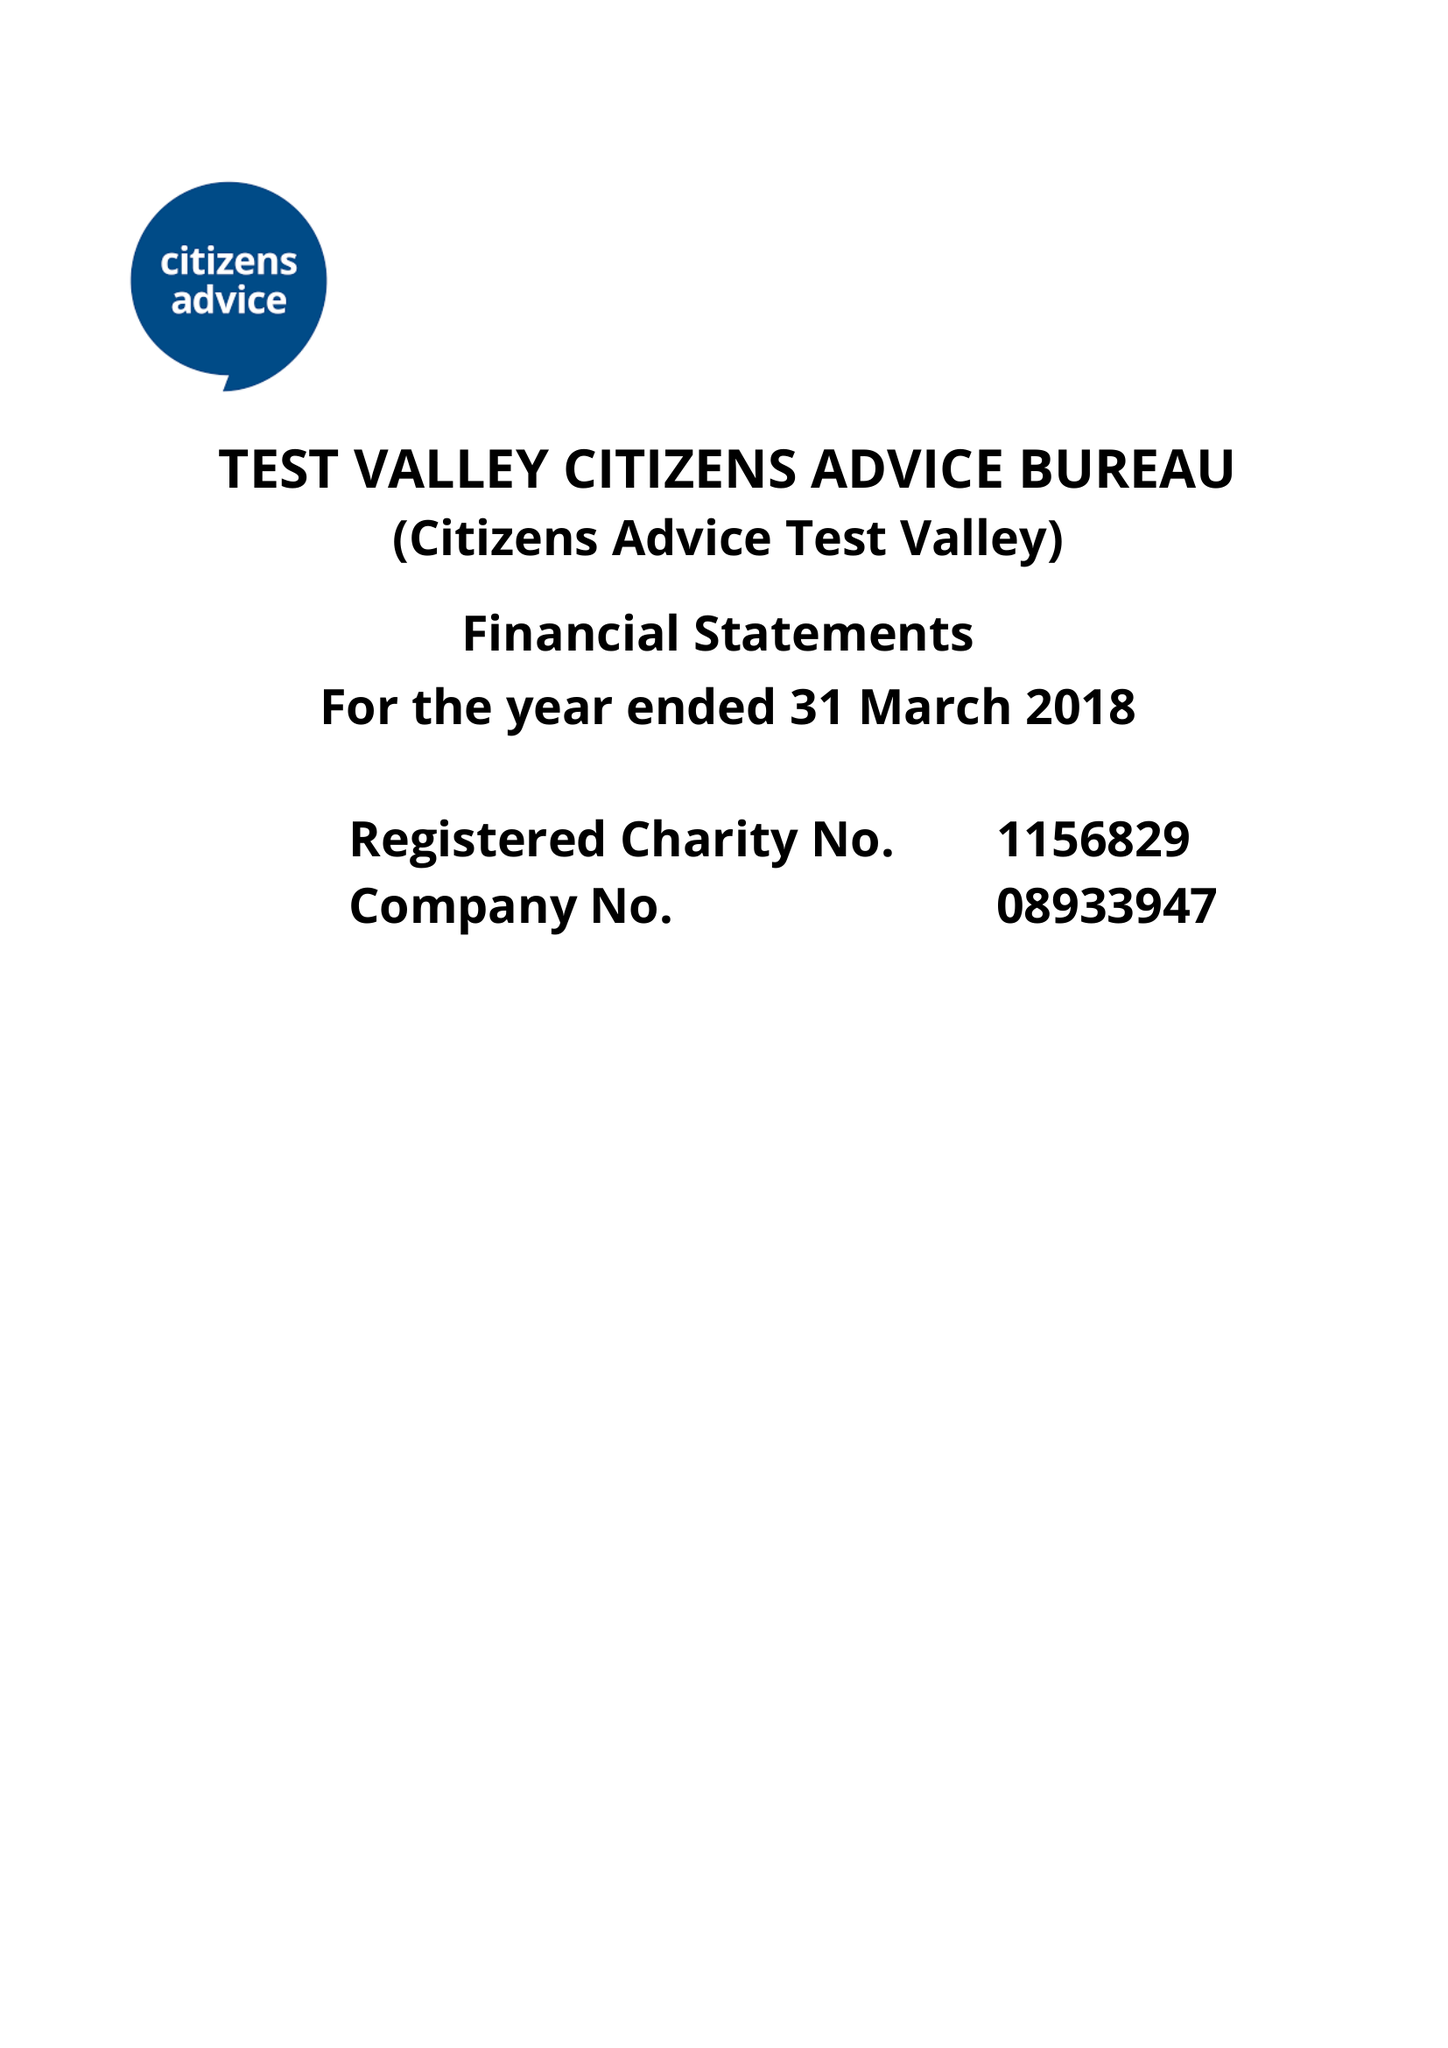What is the value for the report_date?
Answer the question using a single word or phrase. 2018-03-31 